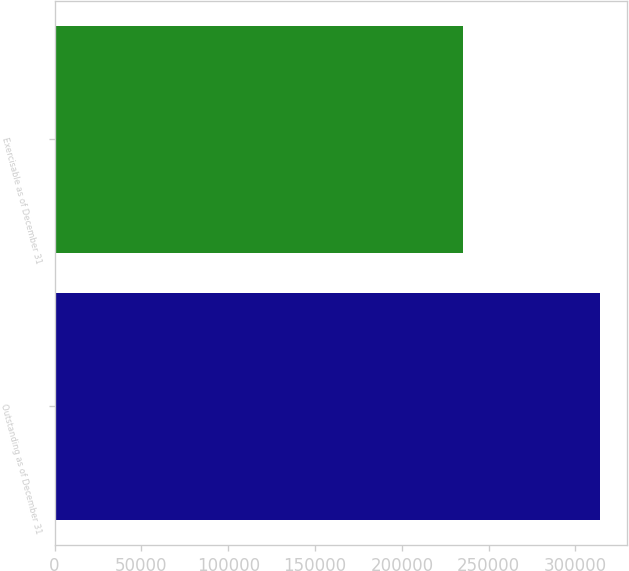<chart> <loc_0><loc_0><loc_500><loc_500><bar_chart><fcel>Outstanding as of December 31<fcel>Exercisable as of December 31<nl><fcel>313855<fcel>235354<nl></chart> 